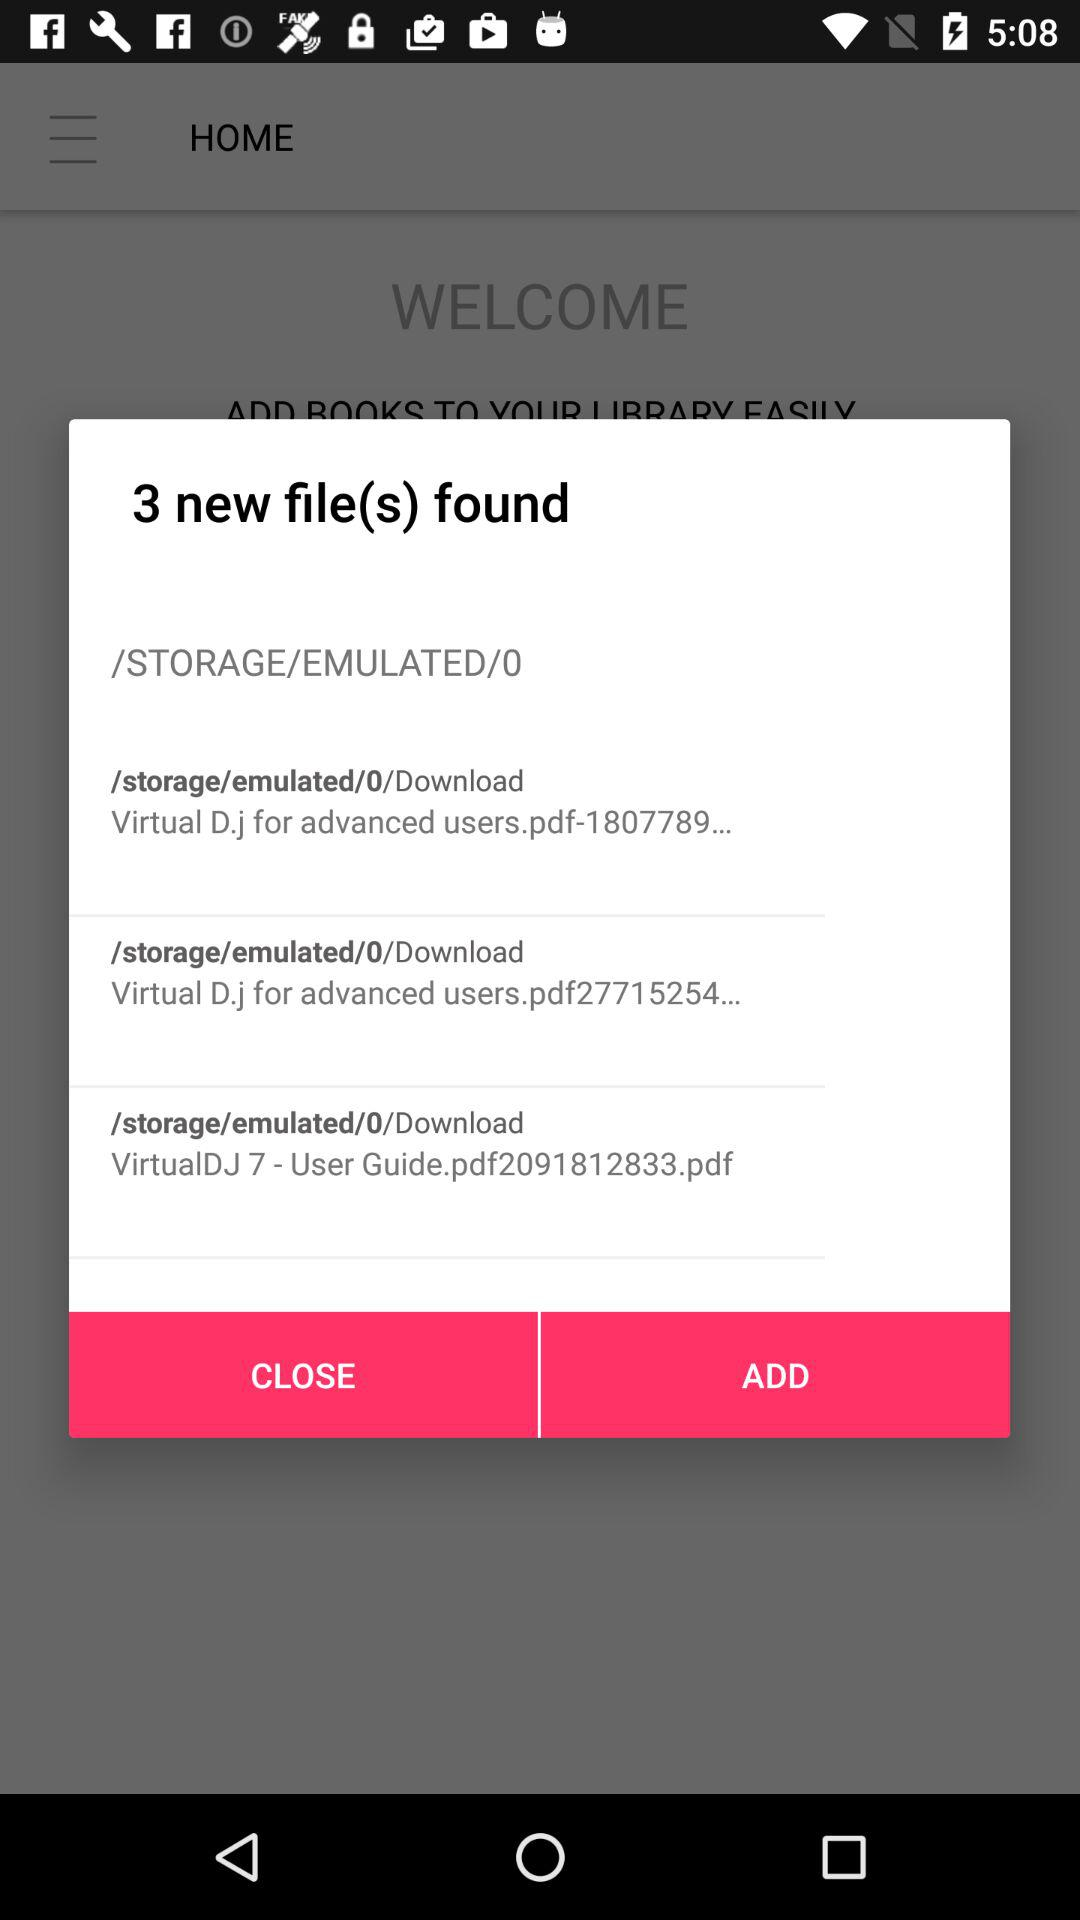How many new files are found? There are 3 new files found. 